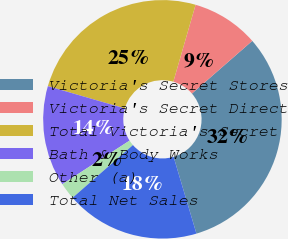Convert chart to OTSL. <chart><loc_0><loc_0><loc_500><loc_500><pie_chart><fcel>Victoria's Secret Stores<fcel>Victoria's Secret Direct<fcel>Total Victoria's Secret<fcel>Bath & Body Works<fcel>Other (a)<fcel>Total Net Sales<nl><fcel>31.82%<fcel>9.09%<fcel>25.0%<fcel>13.64%<fcel>2.27%<fcel>18.18%<nl></chart> 